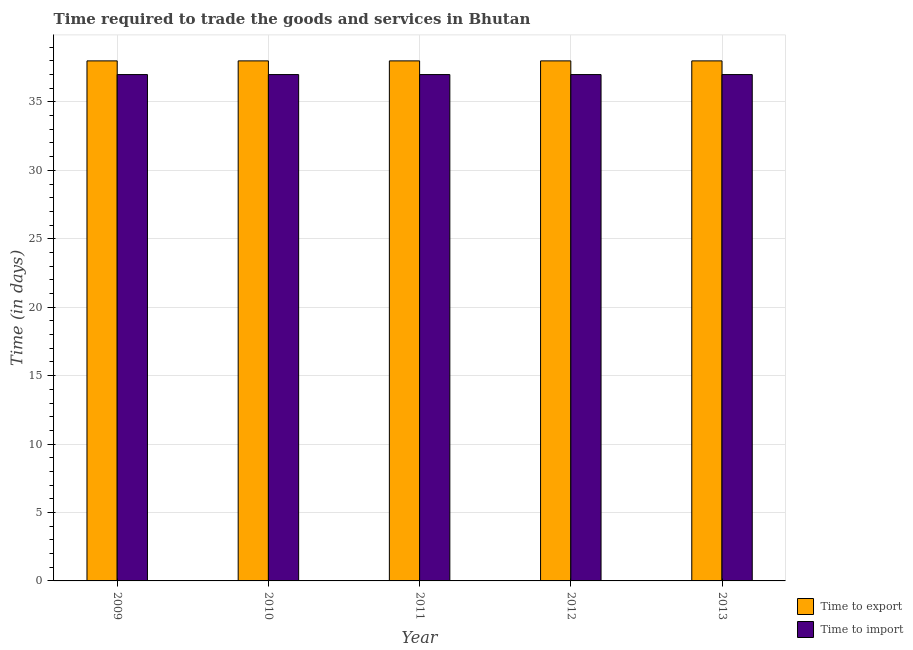How many bars are there on the 5th tick from the left?
Ensure brevity in your answer.  2. How many bars are there on the 3rd tick from the right?
Offer a terse response. 2. What is the time to import in 2011?
Offer a terse response. 37. Across all years, what is the maximum time to export?
Keep it short and to the point. 38. Across all years, what is the minimum time to import?
Offer a terse response. 37. In which year was the time to import maximum?
Your answer should be compact. 2009. In which year was the time to import minimum?
Provide a short and direct response. 2009. What is the total time to import in the graph?
Ensure brevity in your answer.  185. Is the time to import in 2011 less than that in 2012?
Provide a short and direct response. No. Is the difference between the time to import in 2010 and 2012 greater than the difference between the time to export in 2010 and 2012?
Provide a succinct answer. No. What is the difference between the highest and the second highest time to import?
Your response must be concise. 0. What is the difference between the highest and the lowest time to export?
Your answer should be compact. 0. In how many years, is the time to export greater than the average time to export taken over all years?
Your answer should be compact. 0. Is the sum of the time to export in 2011 and 2013 greater than the maximum time to import across all years?
Ensure brevity in your answer.  Yes. What does the 2nd bar from the left in 2012 represents?
Provide a succinct answer. Time to import. What does the 2nd bar from the right in 2010 represents?
Provide a succinct answer. Time to export. Are all the bars in the graph horizontal?
Ensure brevity in your answer.  No. Does the graph contain any zero values?
Provide a succinct answer. No. Does the graph contain grids?
Offer a terse response. Yes. Where does the legend appear in the graph?
Give a very brief answer. Bottom right. How many legend labels are there?
Offer a very short reply. 2. How are the legend labels stacked?
Keep it short and to the point. Vertical. What is the title of the graph?
Ensure brevity in your answer.  Time required to trade the goods and services in Bhutan. What is the label or title of the X-axis?
Offer a very short reply. Year. What is the label or title of the Y-axis?
Offer a very short reply. Time (in days). What is the Time (in days) in Time to import in 2009?
Ensure brevity in your answer.  37. What is the Time (in days) of Time to export in 2012?
Offer a terse response. 38. What is the Time (in days) of Time to export in 2013?
Provide a succinct answer. 38. Across all years, what is the minimum Time (in days) of Time to export?
Make the answer very short. 38. What is the total Time (in days) of Time to export in the graph?
Provide a short and direct response. 190. What is the total Time (in days) in Time to import in the graph?
Offer a terse response. 185. What is the difference between the Time (in days) in Time to import in 2009 and that in 2010?
Give a very brief answer. 0. What is the difference between the Time (in days) of Time to export in 2010 and that in 2011?
Your response must be concise. 0. What is the difference between the Time (in days) of Time to import in 2010 and that in 2012?
Offer a very short reply. 0. What is the difference between the Time (in days) of Time to export in 2010 and that in 2013?
Give a very brief answer. 0. What is the difference between the Time (in days) of Time to import in 2010 and that in 2013?
Give a very brief answer. 0. What is the difference between the Time (in days) of Time to export in 2011 and that in 2012?
Your response must be concise. 0. What is the difference between the Time (in days) in Time to import in 2012 and that in 2013?
Give a very brief answer. 0. What is the difference between the Time (in days) of Time to export in 2009 and the Time (in days) of Time to import in 2010?
Ensure brevity in your answer.  1. What is the difference between the Time (in days) in Time to export in 2009 and the Time (in days) in Time to import in 2013?
Ensure brevity in your answer.  1. What is the difference between the Time (in days) of Time to export in 2010 and the Time (in days) of Time to import in 2012?
Your response must be concise. 1. What is the difference between the Time (in days) in Time to export in 2010 and the Time (in days) in Time to import in 2013?
Keep it short and to the point. 1. What is the difference between the Time (in days) of Time to export in 2011 and the Time (in days) of Time to import in 2012?
Your answer should be very brief. 1. What is the difference between the Time (in days) in Time to export in 2012 and the Time (in days) in Time to import in 2013?
Make the answer very short. 1. What is the average Time (in days) in Time to export per year?
Your answer should be very brief. 38. In the year 2011, what is the difference between the Time (in days) in Time to export and Time (in days) in Time to import?
Make the answer very short. 1. In the year 2012, what is the difference between the Time (in days) in Time to export and Time (in days) in Time to import?
Your answer should be compact. 1. In the year 2013, what is the difference between the Time (in days) in Time to export and Time (in days) in Time to import?
Provide a short and direct response. 1. What is the ratio of the Time (in days) in Time to export in 2009 to that in 2010?
Keep it short and to the point. 1. What is the ratio of the Time (in days) of Time to export in 2009 to that in 2011?
Keep it short and to the point. 1. What is the ratio of the Time (in days) of Time to import in 2009 to that in 2011?
Your answer should be compact. 1. What is the ratio of the Time (in days) of Time to export in 2009 to that in 2013?
Your response must be concise. 1. What is the ratio of the Time (in days) in Time to export in 2010 to that in 2011?
Provide a short and direct response. 1. What is the ratio of the Time (in days) of Time to import in 2010 to that in 2011?
Keep it short and to the point. 1. What is the ratio of the Time (in days) in Time to import in 2010 to that in 2012?
Give a very brief answer. 1. What is the ratio of the Time (in days) in Time to export in 2010 to that in 2013?
Ensure brevity in your answer.  1. What is the ratio of the Time (in days) in Time to import in 2011 to that in 2012?
Your answer should be compact. 1. What is the ratio of the Time (in days) of Time to import in 2011 to that in 2013?
Offer a terse response. 1. What is the ratio of the Time (in days) of Time to export in 2012 to that in 2013?
Offer a very short reply. 1. What is the difference between the highest and the second highest Time (in days) of Time to import?
Your answer should be very brief. 0. 